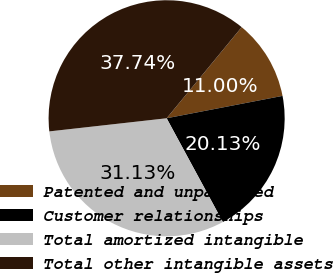Convert chart. <chart><loc_0><loc_0><loc_500><loc_500><pie_chart><fcel>Patented and unpatented<fcel>Customer relationships<fcel>Total amortized intangible<fcel>Total other intangible assets<nl><fcel>11.0%<fcel>20.13%<fcel>31.13%<fcel>37.74%<nl></chart> 